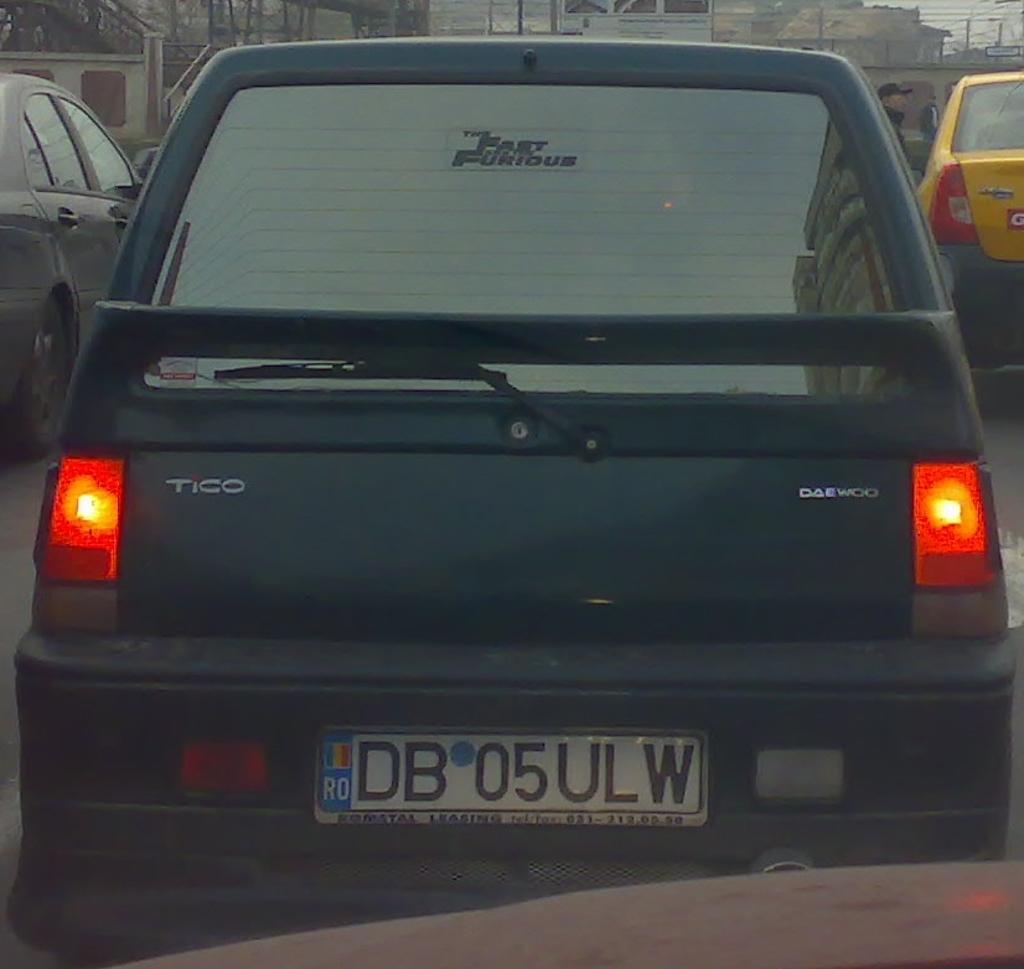What can be seen on the road in the image? There are cars on the road in the image. Can you describe the person in the image? There is a person in the image. What is visible in the background of the image? There are buildings in the background of the image. What type of cake is being served on the sidewalk in the image? There is no cake present in the image; it features cars on the road, a person, and buildings in the background. Can you tell me how many mint leaves are on the person's head in the image? There are no mint leaves present on the person's head in the image. 